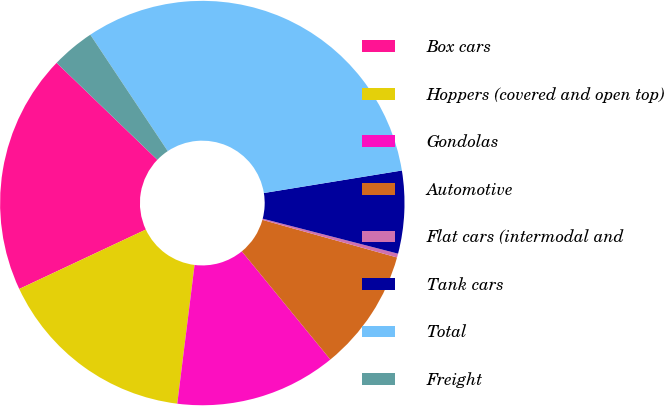<chart> <loc_0><loc_0><loc_500><loc_500><pie_chart><fcel>Box cars<fcel>Hoppers (covered and open top)<fcel>Gondolas<fcel>Automotive<fcel>Flat cars (intermodal and<fcel>Tank cars<fcel>Total<fcel>Freight<nl><fcel>19.18%<fcel>16.04%<fcel>12.89%<fcel>9.75%<fcel>0.31%<fcel>6.6%<fcel>31.77%<fcel>3.46%<nl></chart> 